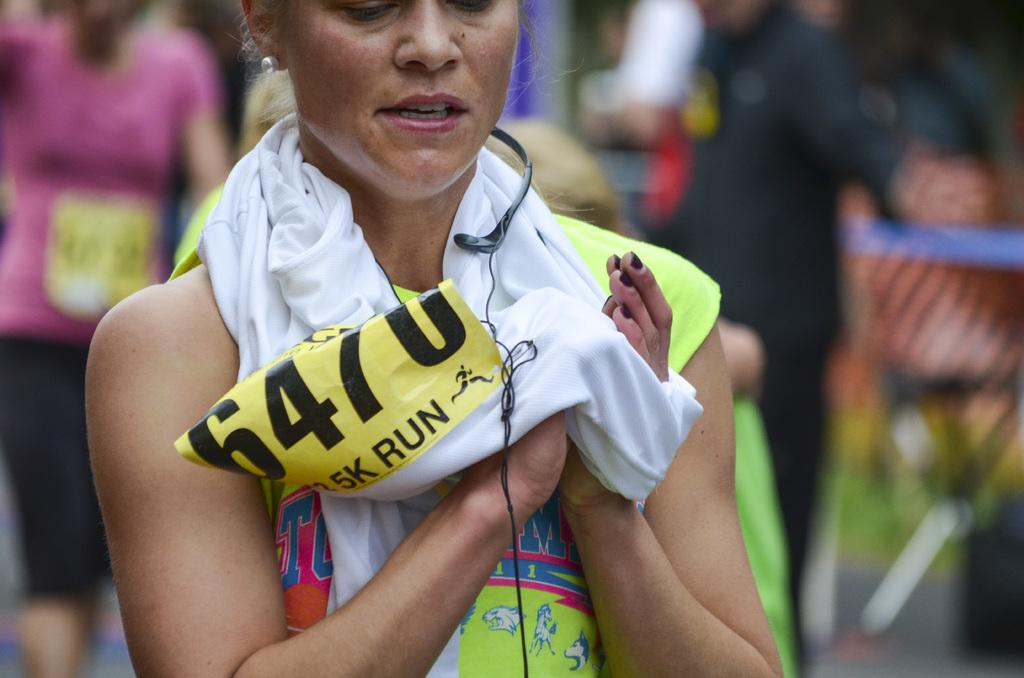<image>
Offer a succinct explanation of the picture presented. A female 5K racer, numbered 6470 takes a minute 